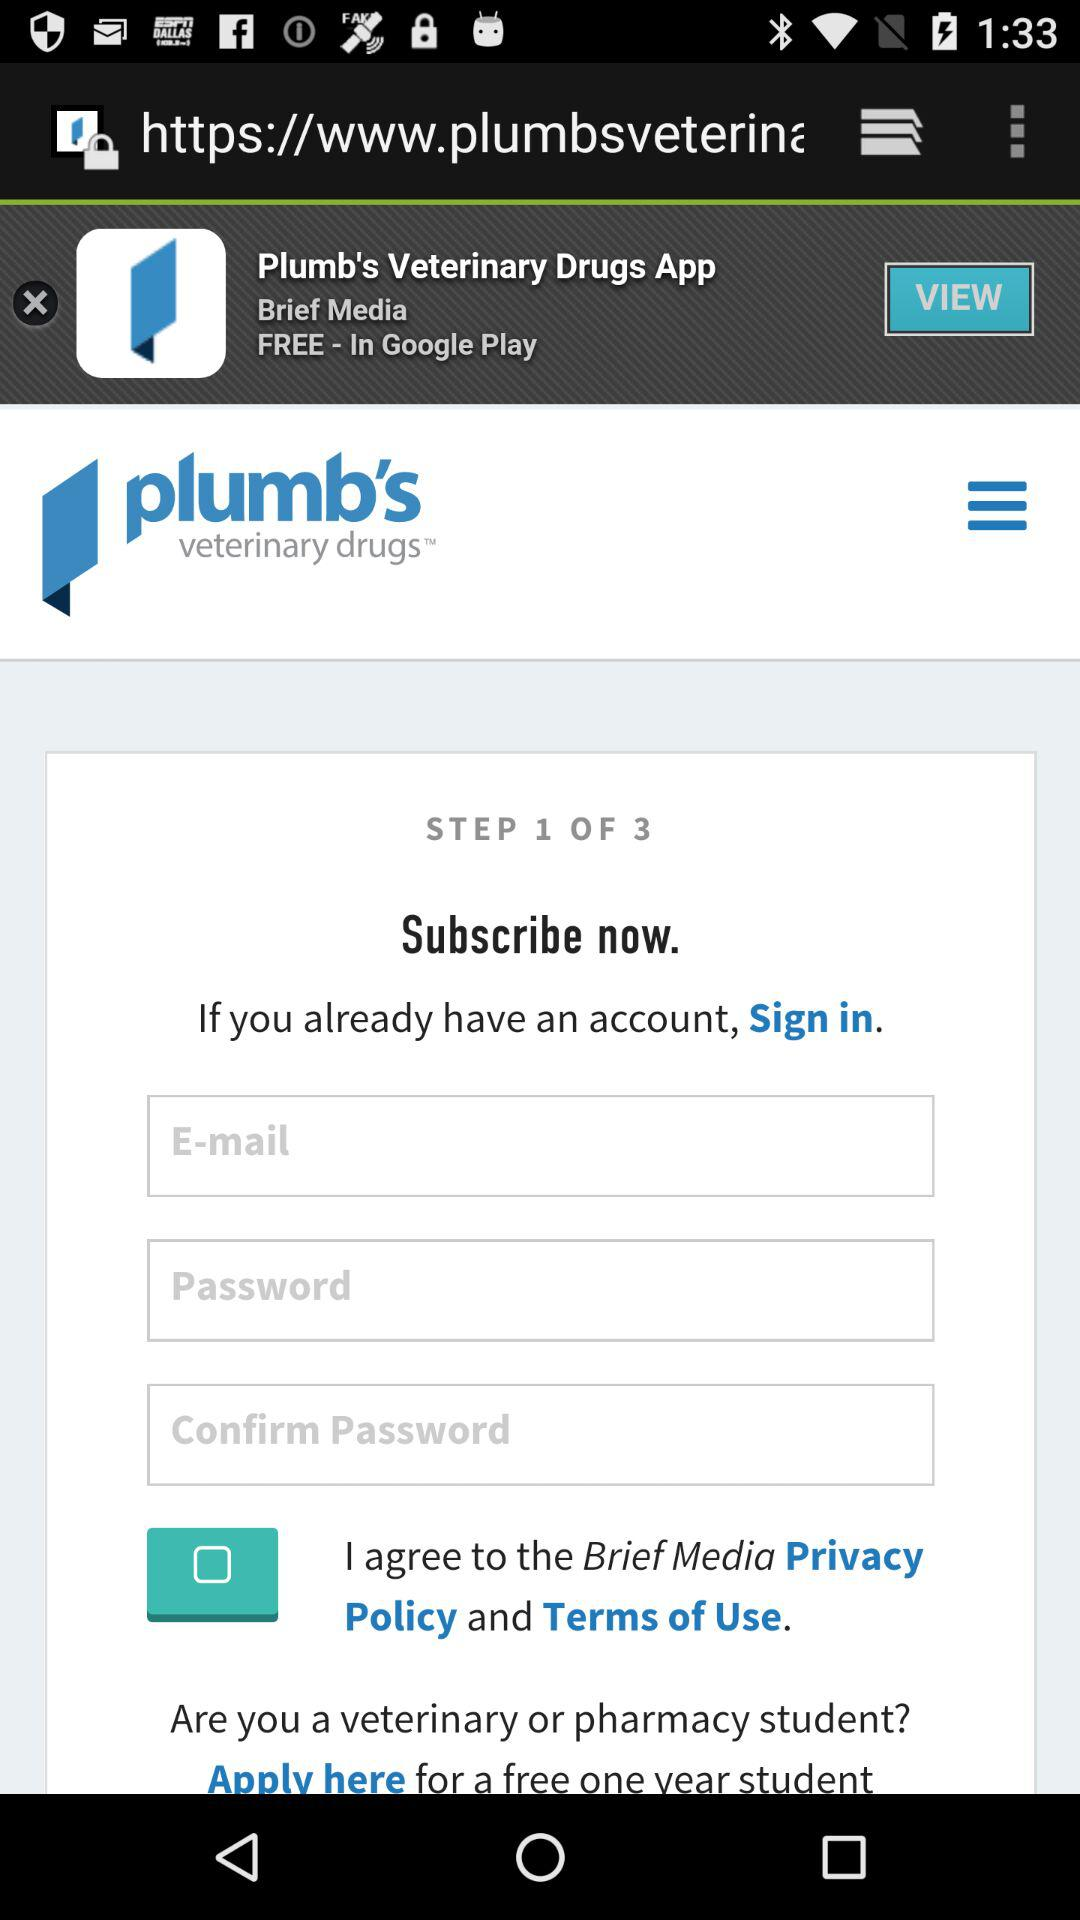What is the status of the option that includes agreement to the "Privacy Policy" and "Terms of Use"? The status is "off". 